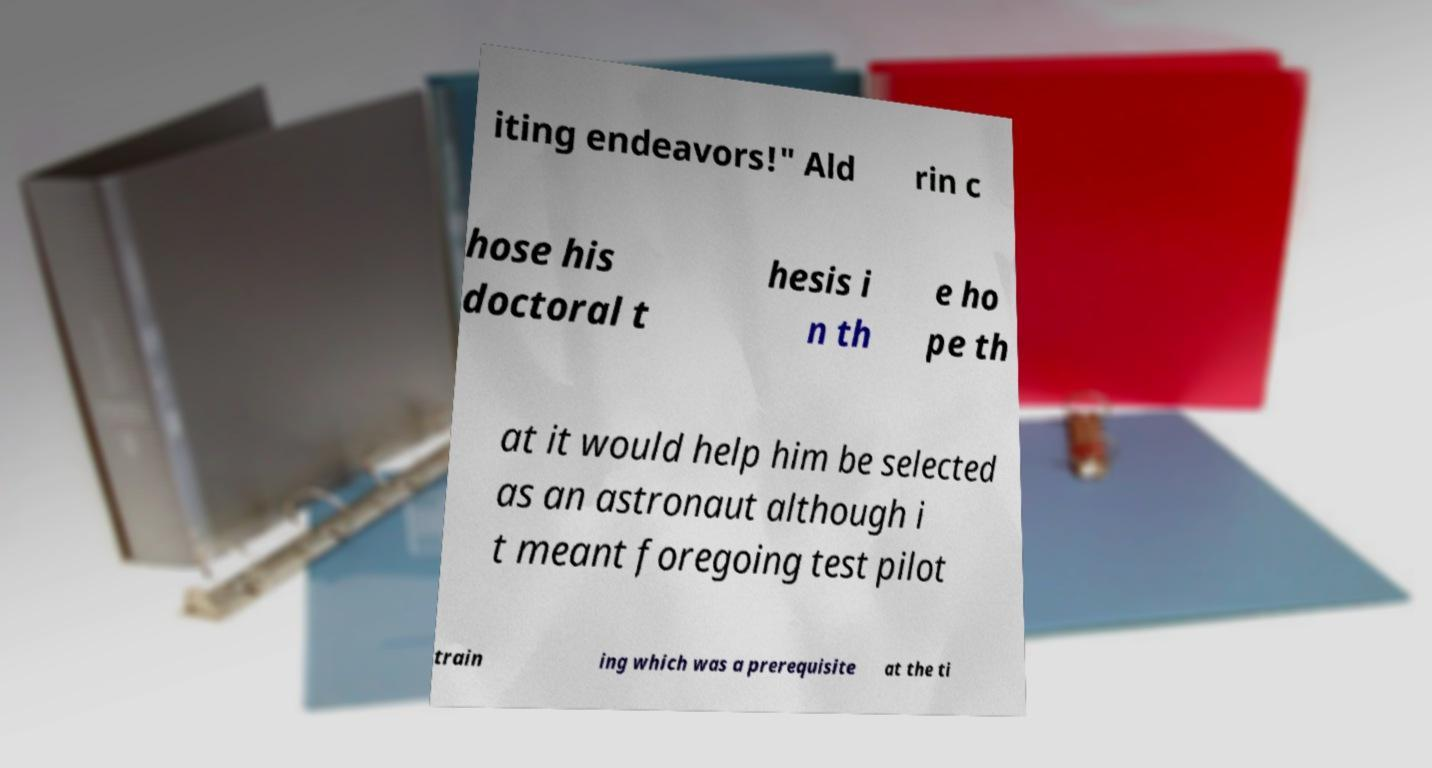For documentation purposes, I need the text within this image transcribed. Could you provide that? iting endeavors!" Ald rin c hose his doctoral t hesis i n th e ho pe th at it would help him be selected as an astronaut although i t meant foregoing test pilot train ing which was a prerequisite at the ti 